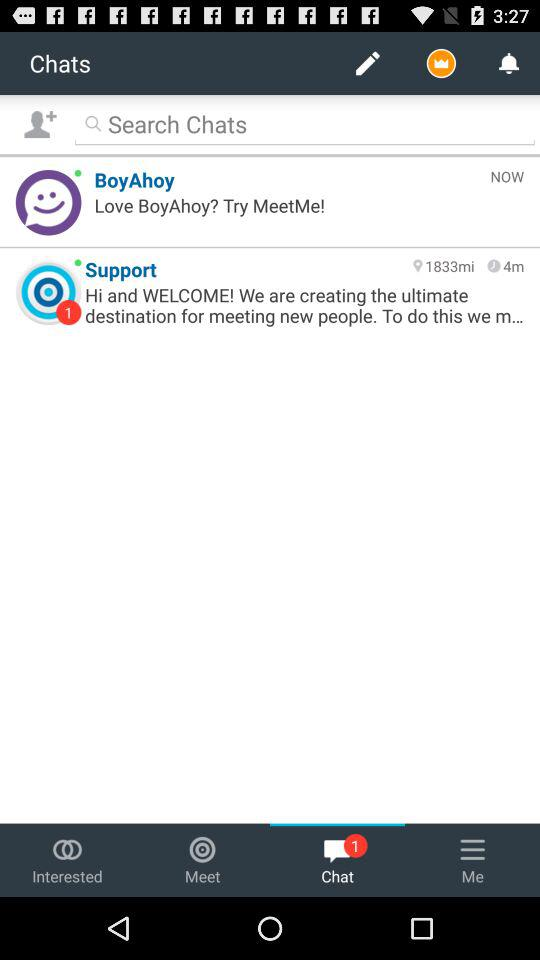How many unread messages are there?
Answer the question using a single word or phrase. 1 